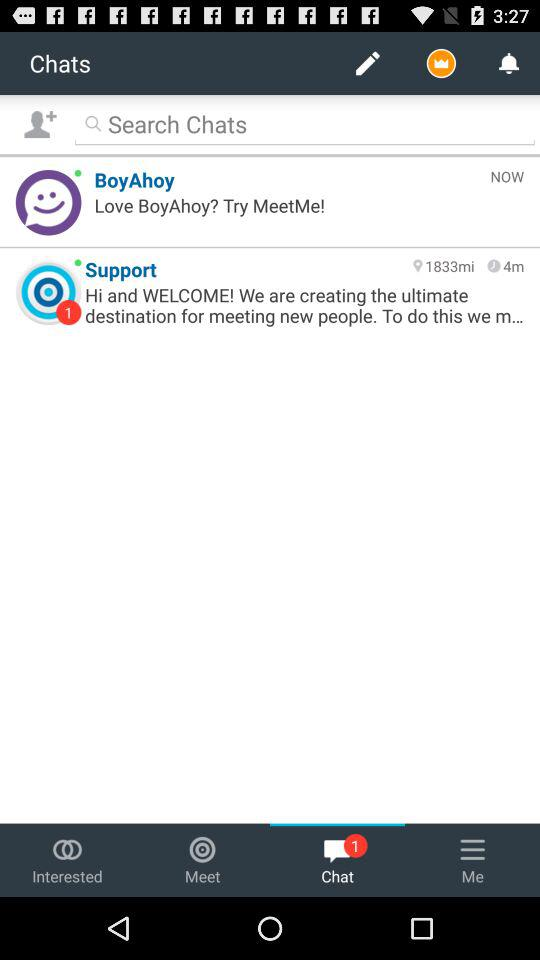How many unread messages are there?
Answer the question using a single word or phrase. 1 